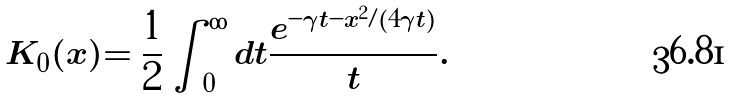Convert formula to latex. <formula><loc_0><loc_0><loc_500><loc_500>K _ { 0 } ( x ) = \frac { 1 } { 2 } \int _ { 0 } ^ { \infty } d t \frac { e ^ { - \gamma t - x ^ { 2 } / ( 4 \gamma t ) } } { t } .</formula> 